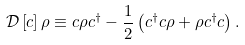Convert formula to latex. <formula><loc_0><loc_0><loc_500><loc_500>\mathcal { D } \left [ c \right ] \rho \equiv c \rho c ^ { \dag } - \frac { 1 } { 2 } \left ( c ^ { \dag } c \rho + \rho c ^ { \dag } c \right ) .</formula> 